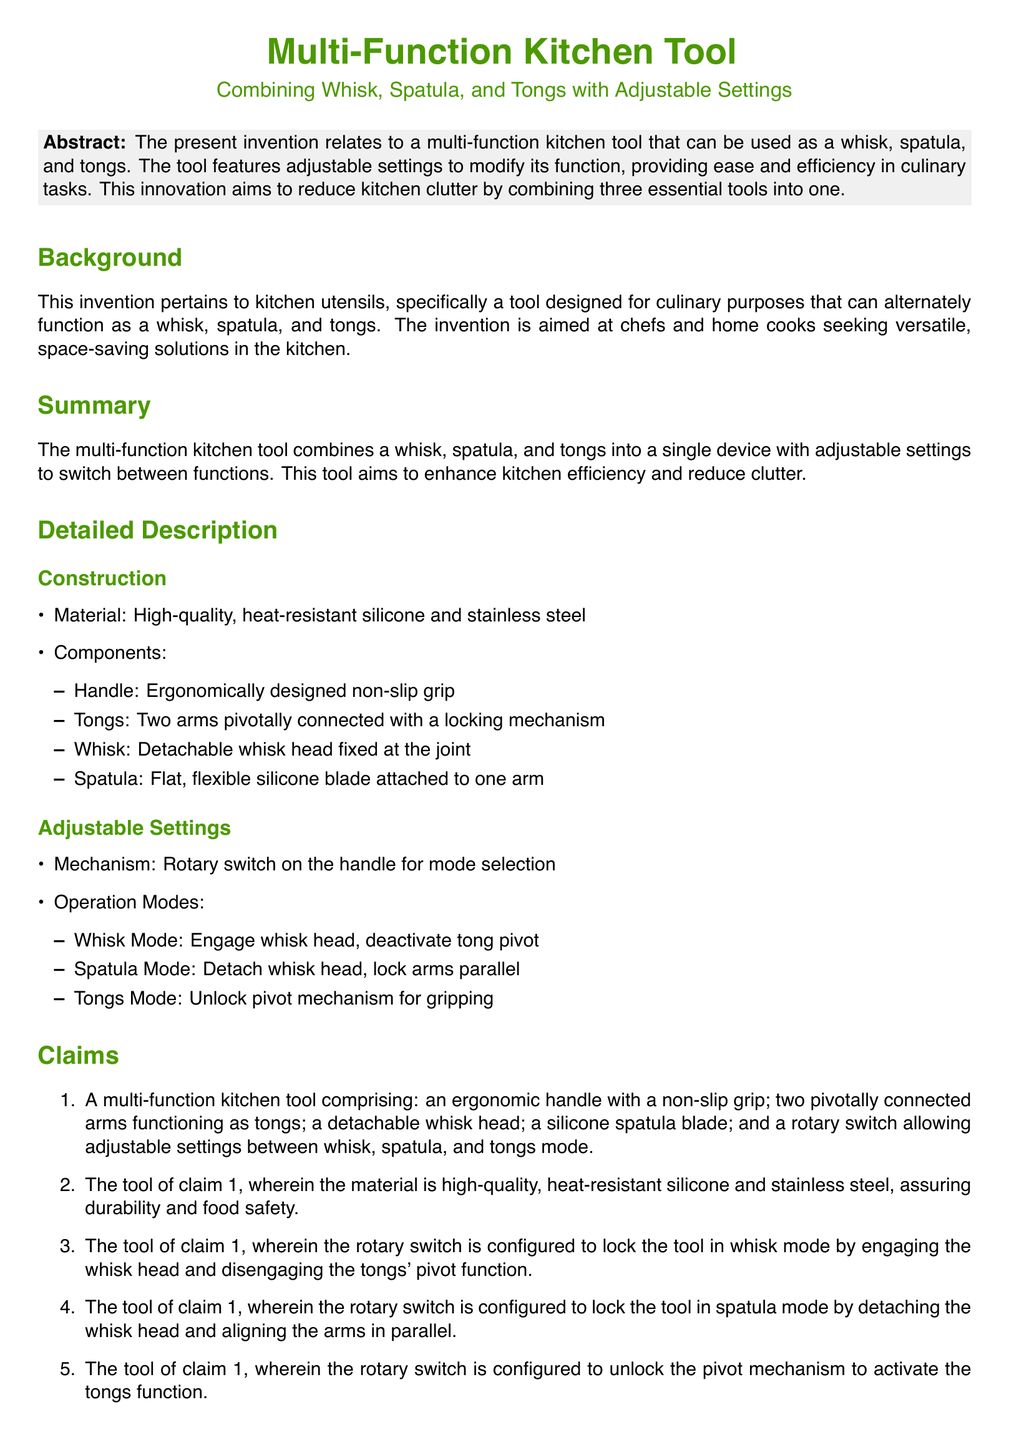What is the purpose of the invention? The invention aims to provide a multi-function kitchen tool that combines three essential tools into one, enhancing efficiency and reducing kitchen clutter.
Answer: To reduce kitchen clutter What materials are used in the construction of the tool? The materials specified in the document for the tool are high-quality, heat-resistant silicone and stainless steel.
Answer: Silicone and stainless steel What is the ergonomic feature of the tool? The ergonomic feature mentioned is a non-slip grip on the handle.
Answer: Non-slip grip How many operation modes does the tool have? The document states three operation modes: whisk mode, spatula mode, and tongs mode.
Answer: Three What does the rotary switch do? The rotary switch allows for adjustable settings to switch between the different modes of the tool.
Answer: Switch modes What is the advantage of combining tools? One primary advantage of combining tools is the space-saving benefit it provides in the kitchen.
Answer: Space-saving What is the locking mechanism for in tongs mode? In tongs mode, the locking mechanism is used to unlock the pivot mechanism for gripping.
Answer: Unlocking pivot mechanism What does the detachable whisk head allow? The detachable whisk head allows the tool to switch between whisk mode and the other two modes.
Answer: Switch to whisk mode What is claimed in the first item of the claims? The first claim specifies the components of the multi-function kitchen tool including the handle, tongs, whisk head, and spatula blade.
Answer: Ergonomic handle, tongs, whisk head, spatula blade 